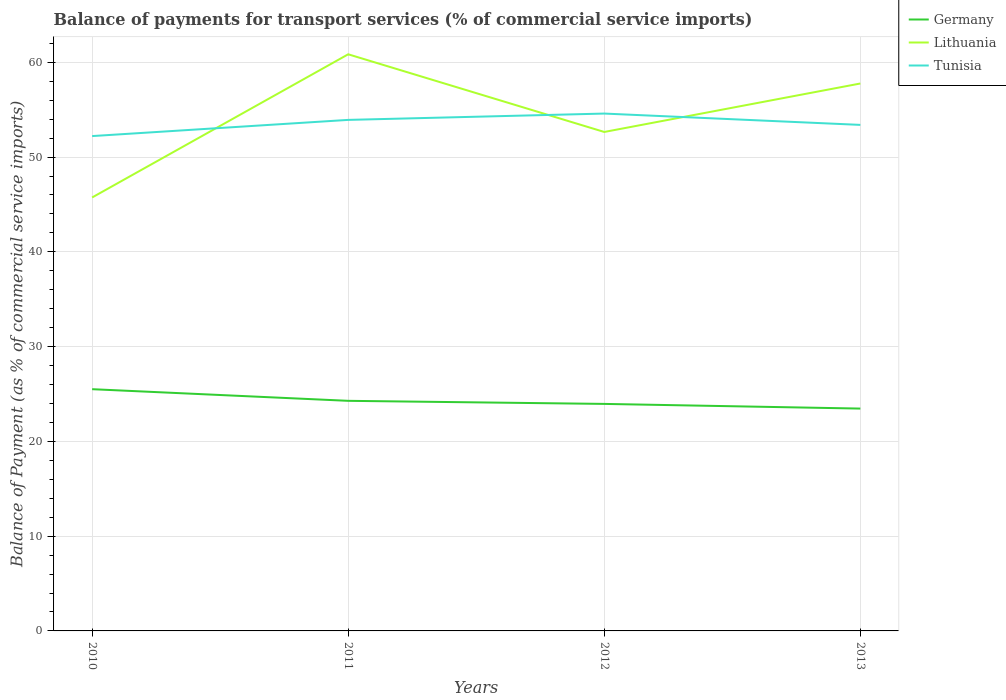How many different coloured lines are there?
Your answer should be compact. 3. Is the number of lines equal to the number of legend labels?
Provide a short and direct response. Yes. Across all years, what is the maximum balance of payments for transport services in Lithuania?
Make the answer very short. 45.74. What is the total balance of payments for transport services in Lithuania in the graph?
Your answer should be very brief. -6.91. What is the difference between the highest and the second highest balance of payments for transport services in Tunisia?
Your response must be concise. 2.38. How many lines are there?
Provide a short and direct response. 3. Are the values on the major ticks of Y-axis written in scientific E-notation?
Provide a short and direct response. No. Does the graph contain any zero values?
Offer a very short reply. No. Does the graph contain grids?
Your response must be concise. Yes. How many legend labels are there?
Offer a terse response. 3. How are the legend labels stacked?
Provide a short and direct response. Vertical. What is the title of the graph?
Provide a succinct answer. Balance of payments for transport services (% of commercial service imports). Does "Dominica" appear as one of the legend labels in the graph?
Give a very brief answer. No. What is the label or title of the X-axis?
Offer a very short reply. Years. What is the label or title of the Y-axis?
Provide a short and direct response. Balance of Payment (as % of commercial service imports). What is the Balance of Payment (as % of commercial service imports) of Germany in 2010?
Make the answer very short. 25.51. What is the Balance of Payment (as % of commercial service imports) in Lithuania in 2010?
Your answer should be very brief. 45.74. What is the Balance of Payment (as % of commercial service imports) of Tunisia in 2010?
Offer a very short reply. 52.22. What is the Balance of Payment (as % of commercial service imports) of Germany in 2011?
Ensure brevity in your answer.  24.28. What is the Balance of Payment (as % of commercial service imports) of Lithuania in 2011?
Offer a terse response. 60.85. What is the Balance of Payment (as % of commercial service imports) of Tunisia in 2011?
Offer a very short reply. 53.93. What is the Balance of Payment (as % of commercial service imports) of Germany in 2012?
Your answer should be compact. 23.96. What is the Balance of Payment (as % of commercial service imports) in Lithuania in 2012?
Make the answer very short. 52.65. What is the Balance of Payment (as % of commercial service imports) of Tunisia in 2012?
Your answer should be compact. 54.59. What is the Balance of Payment (as % of commercial service imports) in Germany in 2013?
Your answer should be compact. 23.46. What is the Balance of Payment (as % of commercial service imports) in Lithuania in 2013?
Give a very brief answer. 57.77. What is the Balance of Payment (as % of commercial service imports) in Tunisia in 2013?
Ensure brevity in your answer.  53.4. Across all years, what is the maximum Balance of Payment (as % of commercial service imports) in Germany?
Provide a short and direct response. 25.51. Across all years, what is the maximum Balance of Payment (as % of commercial service imports) of Lithuania?
Provide a succinct answer. 60.85. Across all years, what is the maximum Balance of Payment (as % of commercial service imports) in Tunisia?
Make the answer very short. 54.59. Across all years, what is the minimum Balance of Payment (as % of commercial service imports) in Germany?
Your answer should be compact. 23.46. Across all years, what is the minimum Balance of Payment (as % of commercial service imports) in Lithuania?
Make the answer very short. 45.74. Across all years, what is the minimum Balance of Payment (as % of commercial service imports) of Tunisia?
Your answer should be compact. 52.22. What is the total Balance of Payment (as % of commercial service imports) of Germany in the graph?
Your response must be concise. 97.21. What is the total Balance of Payment (as % of commercial service imports) in Lithuania in the graph?
Your answer should be very brief. 217. What is the total Balance of Payment (as % of commercial service imports) of Tunisia in the graph?
Your answer should be compact. 214.13. What is the difference between the Balance of Payment (as % of commercial service imports) in Germany in 2010 and that in 2011?
Keep it short and to the point. 1.23. What is the difference between the Balance of Payment (as % of commercial service imports) of Lithuania in 2010 and that in 2011?
Your response must be concise. -15.11. What is the difference between the Balance of Payment (as % of commercial service imports) in Tunisia in 2010 and that in 2011?
Make the answer very short. -1.71. What is the difference between the Balance of Payment (as % of commercial service imports) of Germany in 2010 and that in 2012?
Give a very brief answer. 1.55. What is the difference between the Balance of Payment (as % of commercial service imports) of Lithuania in 2010 and that in 2012?
Provide a succinct answer. -6.91. What is the difference between the Balance of Payment (as % of commercial service imports) of Tunisia in 2010 and that in 2012?
Provide a succinct answer. -2.38. What is the difference between the Balance of Payment (as % of commercial service imports) of Germany in 2010 and that in 2013?
Your answer should be very brief. 2.05. What is the difference between the Balance of Payment (as % of commercial service imports) in Lithuania in 2010 and that in 2013?
Make the answer very short. -12.03. What is the difference between the Balance of Payment (as % of commercial service imports) of Tunisia in 2010 and that in 2013?
Provide a short and direct response. -1.18. What is the difference between the Balance of Payment (as % of commercial service imports) of Germany in 2011 and that in 2012?
Give a very brief answer. 0.32. What is the difference between the Balance of Payment (as % of commercial service imports) in Lithuania in 2011 and that in 2012?
Provide a succinct answer. 8.2. What is the difference between the Balance of Payment (as % of commercial service imports) of Tunisia in 2011 and that in 2012?
Offer a terse response. -0.67. What is the difference between the Balance of Payment (as % of commercial service imports) in Germany in 2011 and that in 2013?
Keep it short and to the point. 0.82. What is the difference between the Balance of Payment (as % of commercial service imports) in Lithuania in 2011 and that in 2013?
Your response must be concise. 3.08. What is the difference between the Balance of Payment (as % of commercial service imports) in Tunisia in 2011 and that in 2013?
Your answer should be very brief. 0.53. What is the difference between the Balance of Payment (as % of commercial service imports) of Germany in 2012 and that in 2013?
Provide a succinct answer. 0.49. What is the difference between the Balance of Payment (as % of commercial service imports) of Lithuania in 2012 and that in 2013?
Your response must be concise. -5.11. What is the difference between the Balance of Payment (as % of commercial service imports) of Tunisia in 2012 and that in 2013?
Provide a short and direct response. 1.2. What is the difference between the Balance of Payment (as % of commercial service imports) in Germany in 2010 and the Balance of Payment (as % of commercial service imports) in Lithuania in 2011?
Keep it short and to the point. -35.34. What is the difference between the Balance of Payment (as % of commercial service imports) in Germany in 2010 and the Balance of Payment (as % of commercial service imports) in Tunisia in 2011?
Give a very brief answer. -28.42. What is the difference between the Balance of Payment (as % of commercial service imports) in Lithuania in 2010 and the Balance of Payment (as % of commercial service imports) in Tunisia in 2011?
Offer a very short reply. -8.19. What is the difference between the Balance of Payment (as % of commercial service imports) in Germany in 2010 and the Balance of Payment (as % of commercial service imports) in Lithuania in 2012?
Your answer should be compact. -27.14. What is the difference between the Balance of Payment (as % of commercial service imports) in Germany in 2010 and the Balance of Payment (as % of commercial service imports) in Tunisia in 2012?
Your response must be concise. -29.08. What is the difference between the Balance of Payment (as % of commercial service imports) in Lithuania in 2010 and the Balance of Payment (as % of commercial service imports) in Tunisia in 2012?
Offer a very short reply. -8.85. What is the difference between the Balance of Payment (as % of commercial service imports) in Germany in 2010 and the Balance of Payment (as % of commercial service imports) in Lithuania in 2013?
Offer a terse response. -32.26. What is the difference between the Balance of Payment (as % of commercial service imports) in Germany in 2010 and the Balance of Payment (as % of commercial service imports) in Tunisia in 2013?
Provide a succinct answer. -27.89. What is the difference between the Balance of Payment (as % of commercial service imports) of Lithuania in 2010 and the Balance of Payment (as % of commercial service imports) of Tunisia in 2013?
Offer a terse response. -7.66. What is the difference between the Balance of Payment (as % of commercial service imports) of Germany in 2011 and the Balance of Payment (as % of commercial service imports) of Lithuania in 2012?
Your answer should be compact. -28.37. What is the difference between the Balance of Payment (as % of commercial service imports) of Germany in 2011 and the Balance of Payment (as % of commercial service imports) of Tunisia in 2012?
Keep it short and to the point. -30.31. What is the difference between the Balance of Payment (as % of commercial service imports) in Lithuania in 2011 and the Balance of Payment (as % of commercial service imports) in Tunisia in 2012?
Offer a terse response. 6.25. What is the difference between the Balance of Payment (as % of commercial service imports) in Germany in 2011 and the Balance of Payment (as % of commercial service imports) in Lithuania in 2013?
Provide a short and direct response. -33.49. What is the difference between the Balance of Payment (as % of commercial service imports) in Germany in 2011 and the Balance of Payment (as % of commercial service imports) in Tunisia in 2013?
Keep it short and to the point. -29.12. What is the difference between the Balance of Payment (as % of commercial service imports) in Lithuania in 2011 and the Balance of Payment (as % of commercial service imports) in Tunisia in 2013?
Offer a very short reply. 7.45. What is the difference between the Balance of Payment (as % of commercial service imports) of Germany in 2012 and the Balance of Payment (as % of commercial service imports) of Lithuania in 2013?
Keep it short and to the point. -33.81. What is the difference between the Balance of Payment (as % of commercial service imports) of Germany in 2012 and the Balance of Payment (as % of commercial service imports) of Tunisia in 2013?
Keep it short and to the point. -29.44. What is the difference between the Balance of Payment (as % of commercial service imports) of Lithuania in 2012 and the Balance of Payment (as % of commercial service imports) of Tunisia in 2013?
Your response must be concise. -0.75. What is the average Balance of Payment (as % of commercial service imports) of Germany per year?
Ensure brevity in your answer.  24.3. What is the average Balance of Payment (as % of commercial service imports) in Lithuania per year?
Your answer should be very brief. 54.25. What is the average Balance of Payment (as % of commercial service imports) in Tunisia per year?
Offer a very short reply. 53.53. In the year 2010, what is the difference between the Balance of Payment (as % of commercial service imports) in Germany and Balance of Payment (as % of commercial service imports) in Lithuania?
Your answer should be compact. -20.23. In the year 2010, what is the difference between the Balance of Payment (as % of commercial service imports) of Germany and Balance of Payment (as % of commercial service imports) of Tunisia?
Provide a succinct answer. -26.71. In the year 2010, what is the difference between the Balance of Payment (as % of commercial service imports) of Lithuania and Balance of Payment (as % of commercial service imports) of Tunisia?
Offer a terse response. -6.48. In the year 2011, what is the difference between the Balance of Payment (as % of commercial service imports) in Germany and Balance of Payment (as % of commercial service imports) in Lithuania?
Your response must be concise. -36.57. In the year 2011, what is the difference between the Balance of Payment (as % of commercial service imports) in Germany and Balance of Payment (as % of commercial service imports) in Tunisia?
Your answer should be very brief. -29.65. In the year 2011, what is the difference between the Balance of Payment (as % of commercial service imports) in Lithuania and Balance of Payment (as % of commercial service imports) in Tunisia?
Provide a succinct answer. 6.92. In the year 2012, what is the difference between the Balance of Payment (as % of commercial service imports) of Germany and Balance of Payment (as % of commercial service imports) of Lithuania?
Provide a succinct answer. -28.7. In the year 2012, what is the difference between the Balance of Payment (as % of commercial service imports) in Germany and Balance of Payment (as % of commercial service imports) in Tunisia?
Your answer should be compact. -30.64. In the year 2012, what is the difference between the Balance of Payment (as % of commercial service imports) in Lithuania and Balance of Payment (as % of commercial service imports) in Tunisia?
Your answer should be very brief. -1.94. In the year 2013, what is the difference between the Balance of Payment (as % of commercial service imports) of Germany and Balance of Payment (as % of commercial service imports) of Lithuania?
Keep it short and to the point. -34.3. In the year 2013, what is the difference between the Balance of Payment (as % of commercial service imports) in Germany and Balance of Payment (as % of commercial service imports) in Tunisia?
Your response must be concise. -29.94. In the year 2013, what is the difference between the Balance of Payment (as % of commercial service imports) of Lithuania and Balance of Payment (as % of commercial service imports) of Tunisia?
Your response must be concise. 4.37. What is the ratio of the Balance of Payment (as % of commercial service imports) of Germany in 2010 to that in 2011?
Provide a short and direct response. 1.05. What is the ratio of the Balance of Payment (as % of commercial service imports) in Lithuania in 2010 to that in 2011?
Ensure brevity in your answer.  0.75. What is the ratio of the Balance of Payment (as % of commercial service imports) of Tunisia in 2010 to that in 2011?
Keep it short and to the point. 0.97. What is the ratio of the Balance of Payment (as % of commercial service imports) of Germany in 2010 to that in 2012?
Keep it short and to the point. 1.06. What is the ratio of the Balance of Payment (as % of commercial service imports) in Lithuania in 2010 to that in 2012?
Ensure brevity in your answer.  0.87. What is the ratio of the Balance of Payment (as % of commercial service imports) of Tunisia in 2010 to that in 2012?
Give a very brief answer. 0.96. What is the ratio of the Balance of Payment (as % of commercial service imports) in Germany in 2010 to that in 2013?
Offer a terse response. 1.09. What is the ratio of the Balance of Payment (as % of commercial service imports) of Lithuania in 2010 to that in 2013?
Your response must be concise. 0.79. What is the ratio of the Balance of Payment (as % of commercial service imports) in Tunisia in 2010 to that in 2013?
Your answer should be compact. 0.98. What is the ratio of the Balance of Payment (as % of commercial service imports) in Germany in 2011 to that in 2012?
Ensure brevity in your answer.  1.01. What is the ratio of the Balance of Payment (as % of commercial service imports) of Lithuania in 2011 to that in 2012?
Offer a very short reply. 1.16. What is the ratio of the Balance of Payment (as % of commercial service imports) of Tunisia in 2011 to that in 2012?
Give a very brief answer. 0.99. What is the ratio of the Balance of Payment (as % of commercial service imports) of Germany in 2011 to that in 2013?
Your answer should be compact. 1.03. What is the ratio of the Balance of Payment (as % of commercial service imports) of Lithuania in 2011 to that in 2013?
Keep it short and to the point. 1.05. What is the ratio of the Balance of Payment (as % of commercial service imports) in Tunisia in 2011 to that in 2013?
Give a very brief answer. 1.01. What is the ratio of the Balance of Payment (as % of commercial service imports) of Germany in 2012 to that in 2013?
Your answer should be compact. 1.02. What is the ratio of the Balance of Payment (as % of commercial service imports) of Lithuania in 2012 to that in 2013?
Give a very brief answer. 0.91. What is the ratio of the Balance of Payment (as % of commercial service imports) in Tunisia in 2012 to that in 2013?
Provide a short and direct response. 1.02. What is the difference between the highest and the second highest Balance of Payment (as % of commercial service imports) of Germany?
Ensure brevity in your answer.  1.23. What is the difference between the highest and the second highest Balance of Payment (as % of commercial service imports) of Lithuania?
Your response must be concise. 3.08. What is the difference between the highest and the second highest Balance of Payment (as % of commercial service imports) in Tunisia?
Offer a terse response. 0.67. What is the difference between the highest and the lowest Balance of Payment (as % of commercial service imports) in Germany?
Provide a short and direct response. 2.05. What is the difference between the highest and the lowest Balance of Payment (as % of commercial service imports) of Lithuania?
Your answer should be compact. 15.11. What is the difference between the highest and the lowest Balance of Payment (as % of commercial service imports) of Tunisia?
Keep it short and to the point. 2.38. 